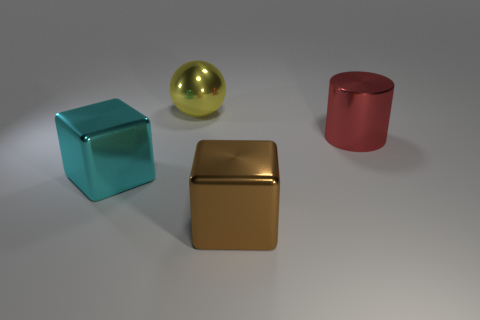Add 4 blocks. How many objects exist? 8 Add 1 large brown objects. How many large brown objects exist? 2 Subtract 0 gray cylinders. How many objects are left? 4 Subtract all cylinders. How many objects are left? 3 Subtract all red things. Subtract all red metal things. How many objects are left? 2 Add 2 large red things. How many large red things are left? 3 